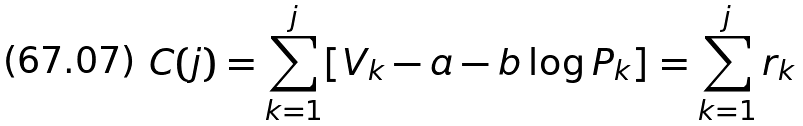Convert formula to latex. <formula><loc_0><loc_0><loc_500><loc_500>C ( j ) = \sum _ { k = 1 } ^ { j } [ V _ { k } - a - b \log P _ { k } ] = \sum _ { k = 1 } ^ { j } r _ { k }</formula> 